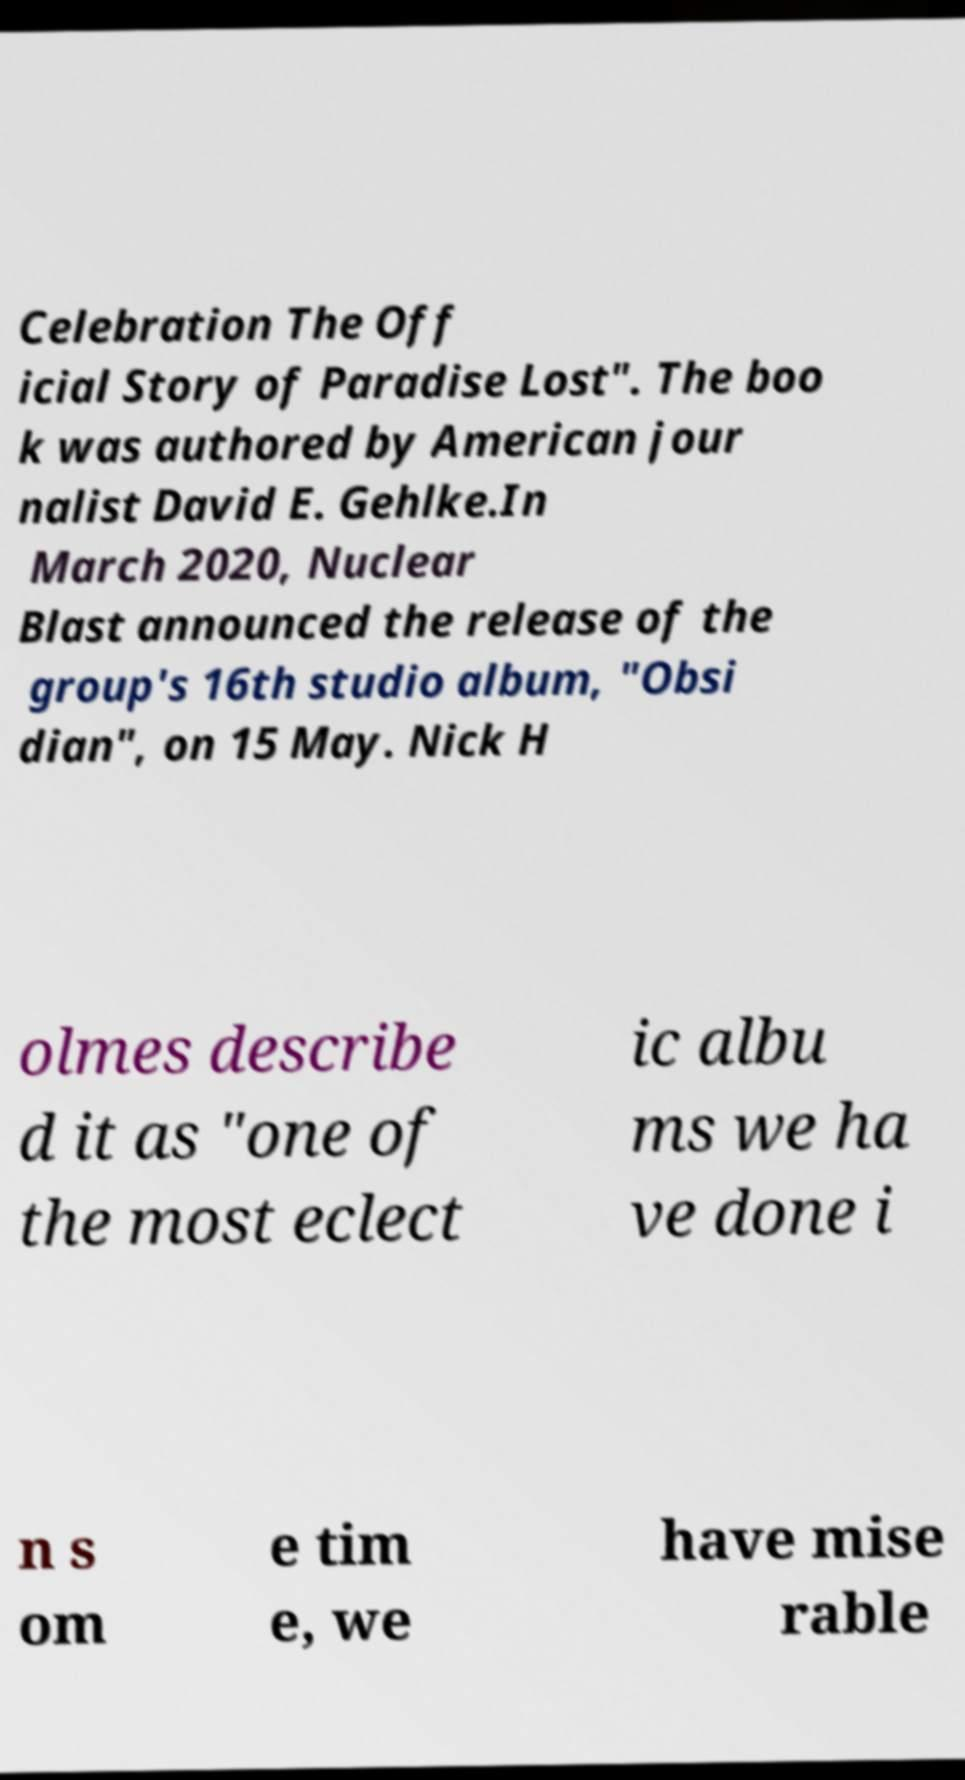What messages or text are displayed in this image? I need them in a readable, typed format. Celebration The Off icial Story of Paradise Lost". The boo k was authored by American jour nalist David E. Gehlke.In March 2020, Nuclear Blast announced the release of the group's 16th studio album, "Obsi dian", on 15 May. Nick H olmes describe d it as "one of the most eclect ic albu ms we ha ve done i n s om e tim e, we have mise rable 